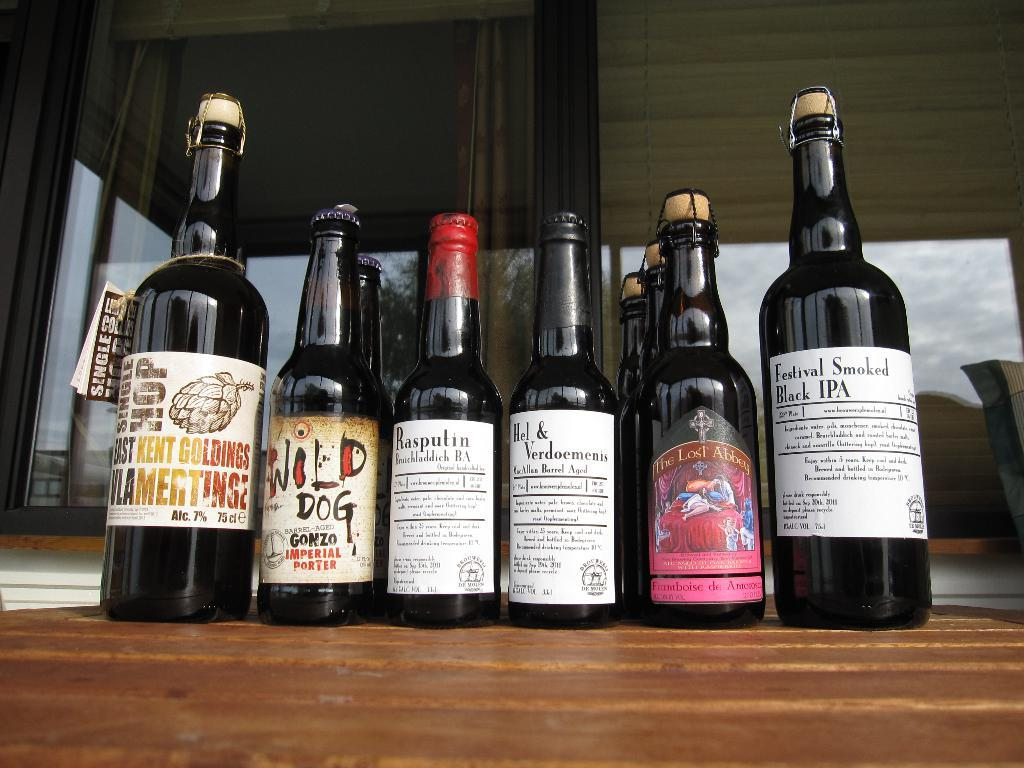<image>
Share a concise interpretation of the image provided. the word black is on one of the bottles 